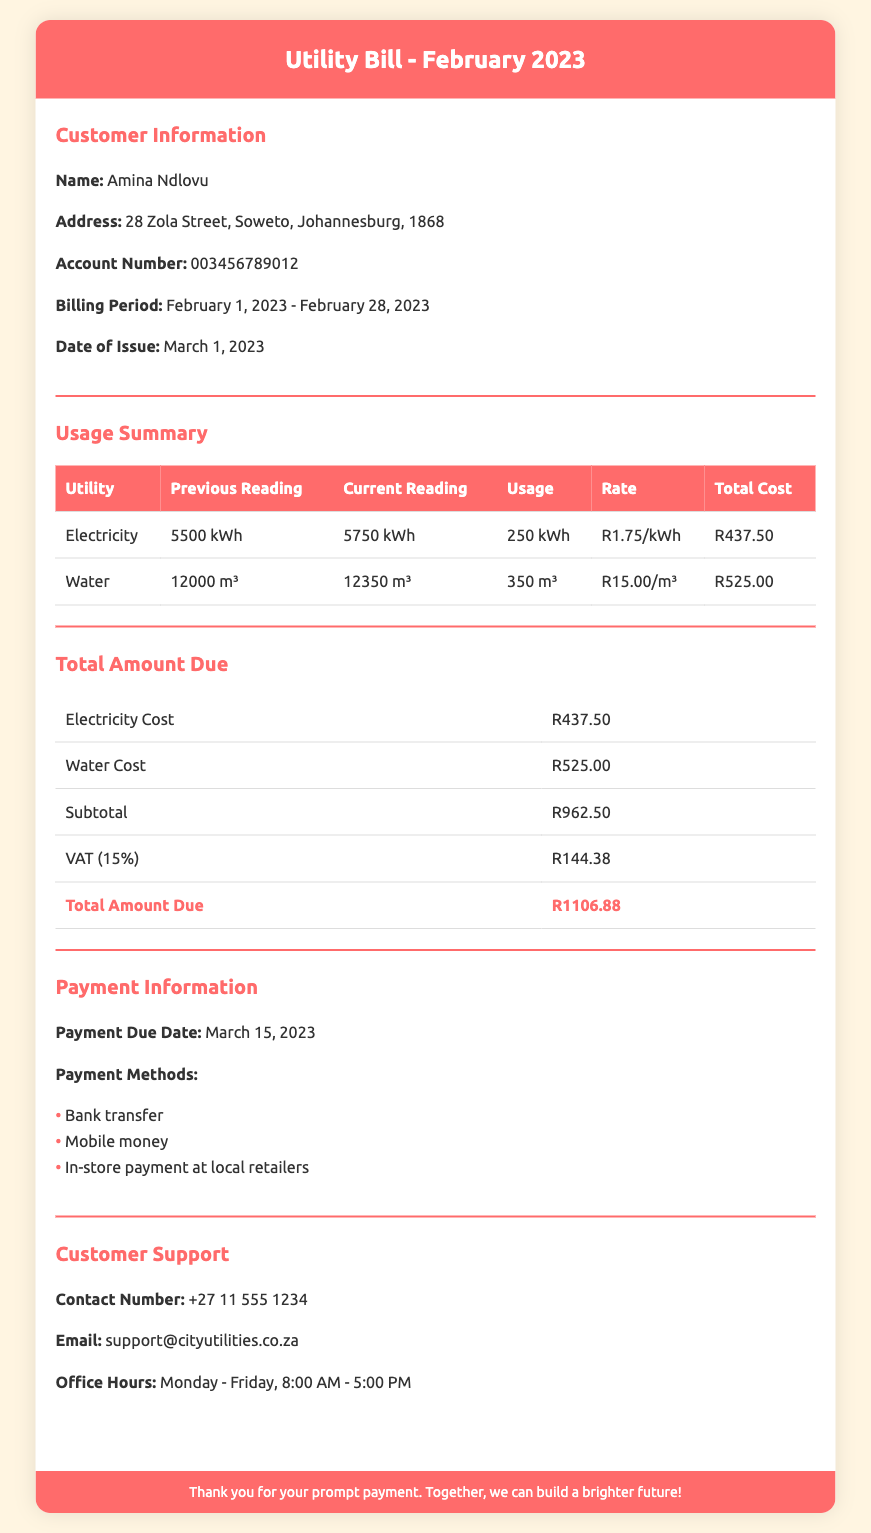What is the customer’s name? The document provides the customer's name in the Customer Information section.
Answer: Amina Ndlovu What is the billing period? The billing period is specified in the Customer Information section.
Answer: February 1, 2023 - February 28, 2023 What is the total amount due? The total amount due is found in the Total Amount Due section.
Answer: R1106.88 How much did the electricity cost? The cost of electricity is detailed in the Total Amount Due section.
Answer: R437.50 What was the previous reading for water usage? The previous reading for water usage can be found in the Usage Summary table.
Answer: 12000 m³ What is the VAT percentage applied? The VAT percentage is mentioned in the Total Amount Due section.
Answer: 15% What were the current readings for electricity? The current readings for electricity can be found in the Usage Summary table.
Answer: 5750 kWh When is the payment due date? The payment due date is specified in the Payment Information section.
Answer: March 15, 2023 Which payment method is not mentioned in the document? The question examines the listed payment methods to find what is absent.
Answer: Cash 